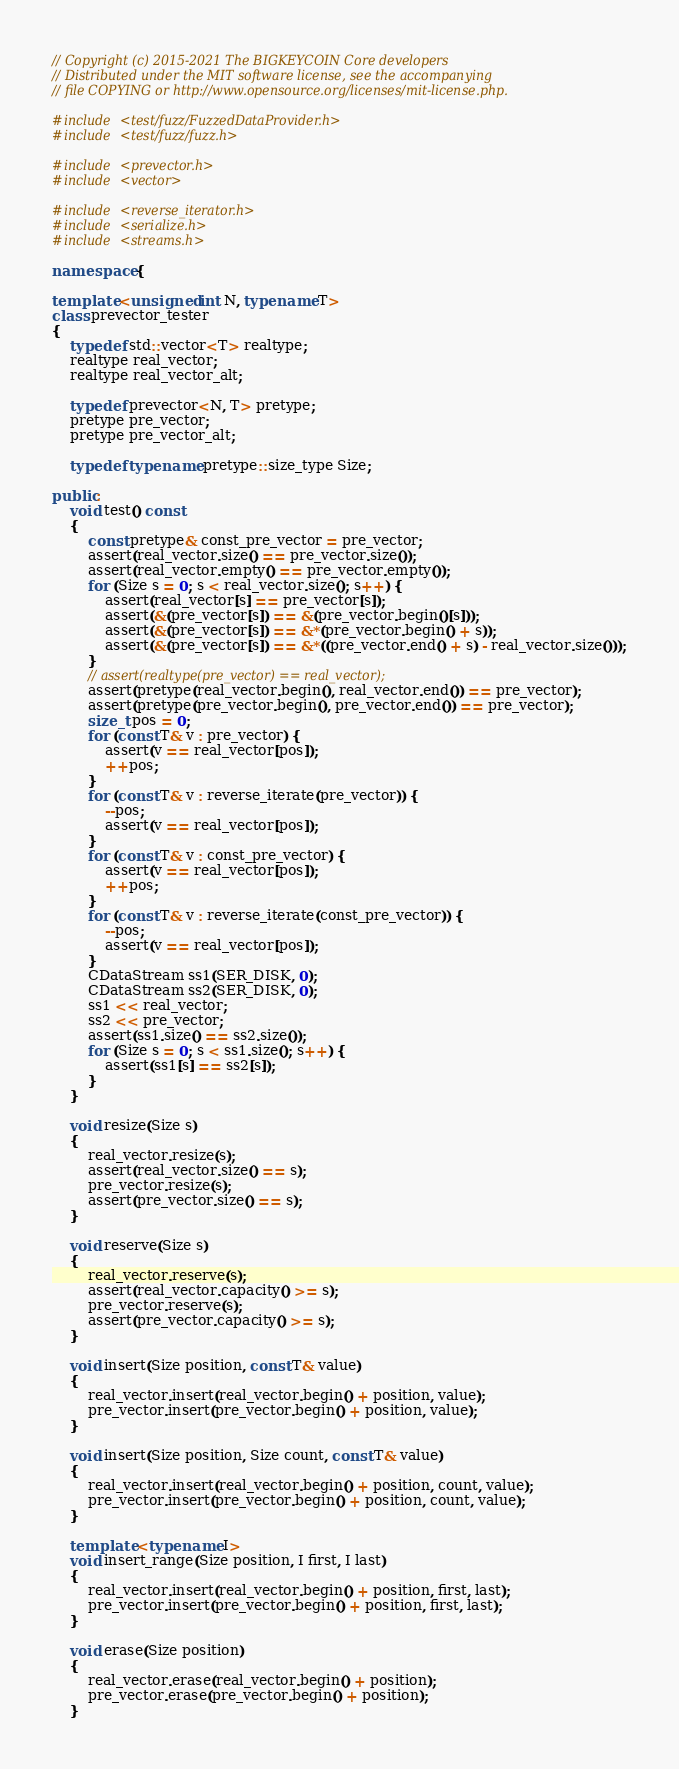Convert code to text. <code><loc_0><loc_0><loc_500><loc_500><_C++_>// Copyright (c) 2015-2021 The BIGKEYCOIN Core developers
// Distributed under the MIT software license, see the accompanying
// file COPYING or http://www.opensource.org/licenses/mit-license.php.

#include <test/fuzz/FuzzedDataProvider.h>
#include <test/fuzz/fuzz.h>

#include <prevector.h>
#include <vector>

#include <reverse_iterator.h>
#include <serialize.h>
#include <streams.h>

namespace {

template <unsigned int N, typename T>
class prevector_tester
{
    typedef std::vector<T> realtype;
    realtype real_vector;
    realtype real_vector_alt;

    typedef prevector<N, T> pretype;
    pretype pre_vector;
    pretype pre_vector_alt;

    typedef typename pretype::size_type Size;

public:
    void test() const
    {
        const pretype& const_pre_vector = pre_vector;
        assert(real_vector.size() == pre_vector.size());
        assert(real_vector.empty() == pre_vector.empty());
        for (Size s = 0; s < real_vector.size(); s++) {
            assert(real_vector[s] == pre_vector[s]);
            assert(&(pre_vector[s]) == &(pre_vector.begin()[s]));
            assert(&(pre_vector[s]) == &*(pre_vector.begin() + s));
            assert(&(pre_vector[s]) == &*((pre_vector.end() + s) - real_vector.size()));
        }
        // assert(realtype(pre_vector) == real_vector);
        assert(pretype(real_vector.begin(), real_vector.end()) == pre_vector);
        assert(pretype(pre_vector.begin(), pre_vector.end()) == pre_vector);
        size_t pos = 0;
        for (const T& v : pre_vector) {
            assert(v == real_vector[pos]);
            ++pos;
        }
        for (const T& v : reverse_iterate(pre_vector)) {
            --pos;
            assert(v == real_vector[pos]);
        }
        for (const T& v : const_pre_vector) {
            assert(v == real_vector[pos]);
            ++pos;
        }
        for (const T& v : reverse_iterate(const_pre_vector)) {
            --pos;
            assert(v == real_vector[pos]);
        }
        CDataStream ss1(SER_DISK, 0);
        CDataStream ss2(SER_DISK, 0);
        ss1 << real_vector;
        ss2 << pre_vector;
        assert(ss1.size() == ss2.size());
        for (Size s = 0; s < ss1.size(); s++) {
            assert(ss1[s] == ss2[s]);
        }
    }

    void resize(Size s)
    {
        real_vector.resize(s);
        assert(real_vector.size() == s);
        pre_vector.resize(s);
        assert(pre_vector.size() == s);
    }

    void reserve(Size s)
    {
        real_vector.reserve(s);
        assert(real_vector.capacity() >= s);
        pre_vector.reserve(s);
        assert(pre_vector.capacity() >= s);
    }

    void insert(Size position, const T& value)
    {
        real_vector.insert(real_vector.begin() + position, value);
        pre_vector.insert(pre_vector.begin() + position, value);
    }

    void insert(Size position, Size count, const T& value)
    {
        real_vector.insert(real_vector.begin() + position, count, value);
        pre_vector.insert(pre_vector.begin() + position, count, value);
    }

    template <typename I>
    void insert_range(Size position, I first, I last)
    {
        real_vector.insert(real_vector.begin() + position, first, last);
        pre_vector.insert(pre_vector.begin() + position, first, last);
    }

    void erase(Size position)
    {
        real_vector.erase(real_vector.begin() + position);
        pre_vector.erase(pre_vector.begin() + position);
    }
</code> 